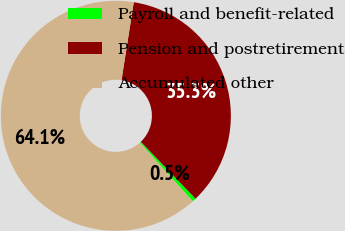<chart> <loc_0><loc_0><loc_500><loc_500><pie_chart><fcel>Payroll and benefit-related<fcel>Pension and postretirement<fcel>Accumulated other<nl><fcel>0.54%<fcel>35.32%<fcel>64.14%<nl></chart> 